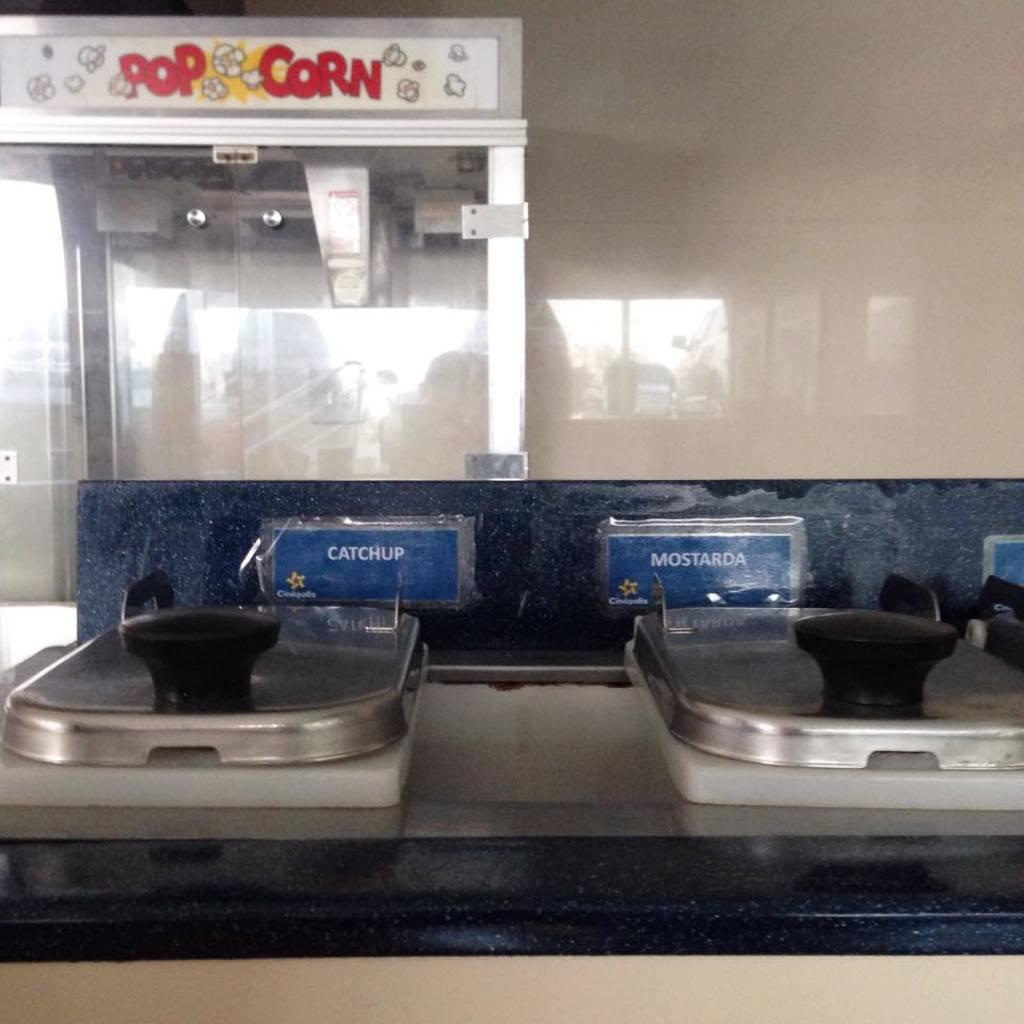What kind of machine is in the background?
Offer a terse response. Popcorn. Can i only have catchup or mostarda ?
Offer a terse response. Yes. 